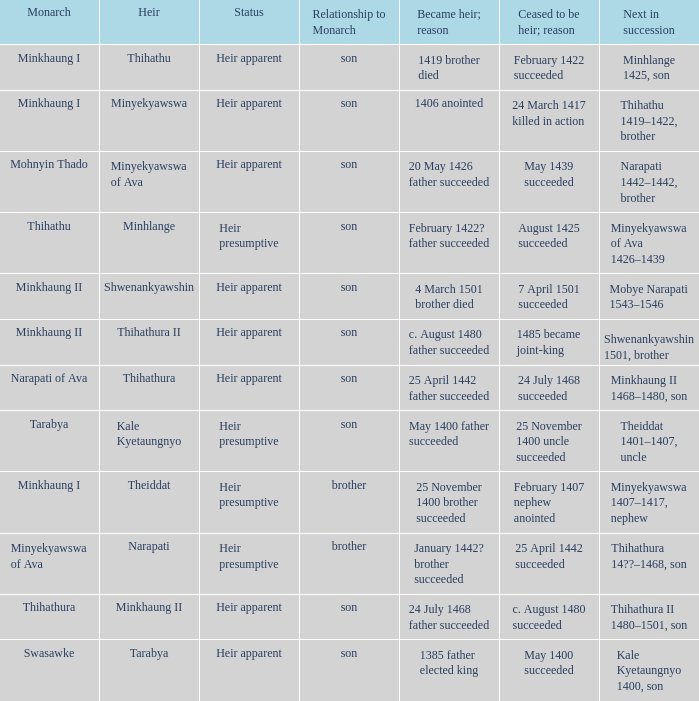What was the relationship to monarch of the heir Minyekyawswa? Son. 